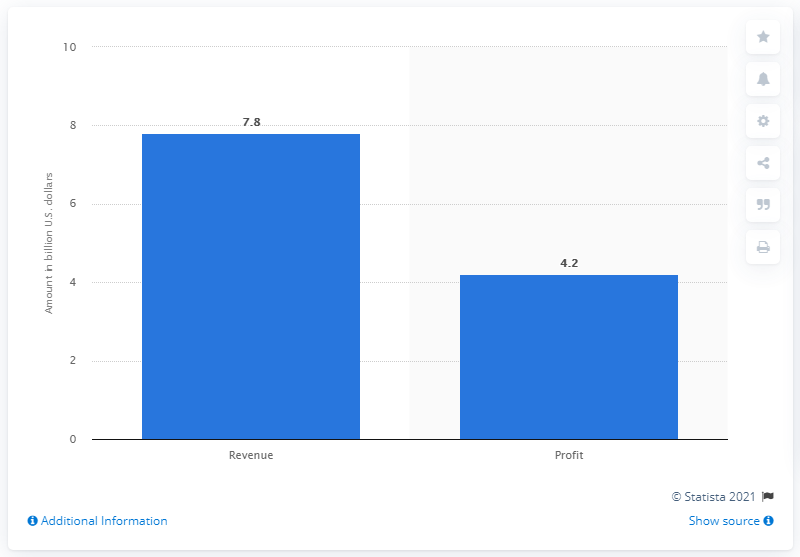Outline some significant characteristics in this image. The estimated profit of the Star Wars sequel trilogy is 4.2 billion dollars. The estimated profit of the Star Wars sequel trilogy is $4.2 billion. 